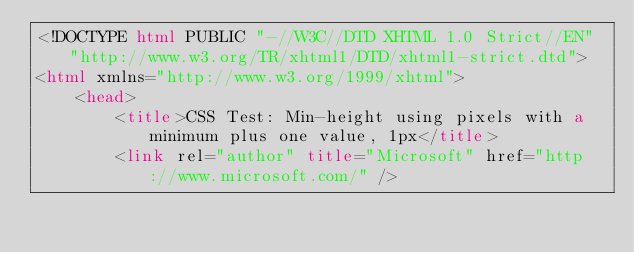Convert code to text. <code><loc_0><loc_0><loc_500><loc_500><_HTML_><!DOCTYPE html PUBLIC "-//W3C//DTD XHTML 1.0 Strict//EN" "http://www.w3.org/TR/xhtml1/DTD/xhtml1-strict.dtd">
<html xmlns="http://www.w3.org/1999/xhtml">
    <head>
        <title>CSS Test: Min-height using pixels with a minimum plus one value, 1px</title>
        <link rel="author" title="Microsoft" href="http://www.microsoft.com/" /></code> 